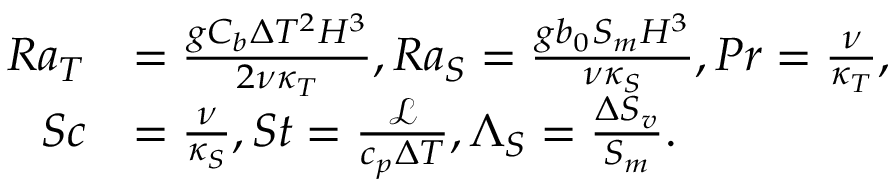<formula> <loc_0><loc_0><loc_500><loc_500>\begin{array} { r l } { R a _ { T } } & { = \frac { g C _ { b } \Delta T ^ { 2 } H ^ { 3 } } { 2 \nu \kappa _ { T } } , R a _ { S } = \frac { g b _ { 0 } S _ { m } H ^ { 3 } } { \nu \kappa _ { S } } , P r = \frac { \nu } { \kappa _ { T } } , } \\ { S c } & { = \frac { \nu } { \kappa _ { S } } , S t = \frac { \mathcal { L } } { c _ { p } \Delta T } , \Lambda _ { S } = \frac { \Delta S _ { v } } { S _ { m } } . } \end{array}</formula> 